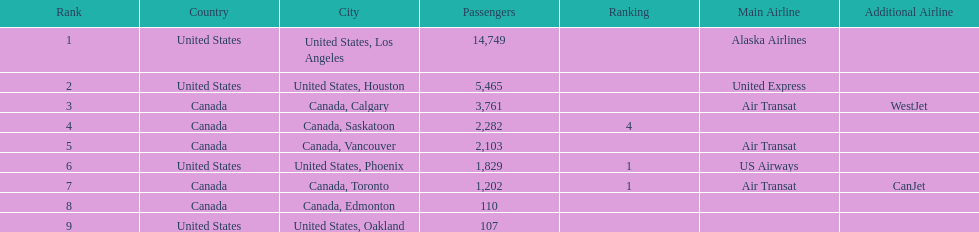Could you parse the entire table as a dict? {'header': ['Rank', 'Country', 'City', 'Passengers', 'Ranking', 'Main Airline', 'Additional Airline'], 'rows': [['1', 'United States', 'United States, Los Angeles', '14,749', '', 'Alaska Airlines', ''], ['2', 'United States', 'United States, Houston', '5,465', '', 'United Express', ''], ['3', 'Canada', 'Canada, Calgary', '3,761', '', 'Air Transat', 'WestJet'], ['4', 'Canada', 'Canada, Saskatoon', '2,282', '4', '', ''], ['5', 'Canada', 'Canada, Vancouver', '2,103', '', 'Air Transat', ''], ['6', 'United States', 'United States, Phoenix', '1,829', '1', 'US Airways', ''], ['7', 'Canada', 'Canada, Toronto', '1,202', '1', 'Air Transat', 'CanJet'], ['8', 'Canada', 'Canada, Edmonton', '110', '', '', ''], ['9', 'United States', 'United States, Oakland', '107', '', '', '']]} The difference in passengers between los angeles and toronto 13,547. 